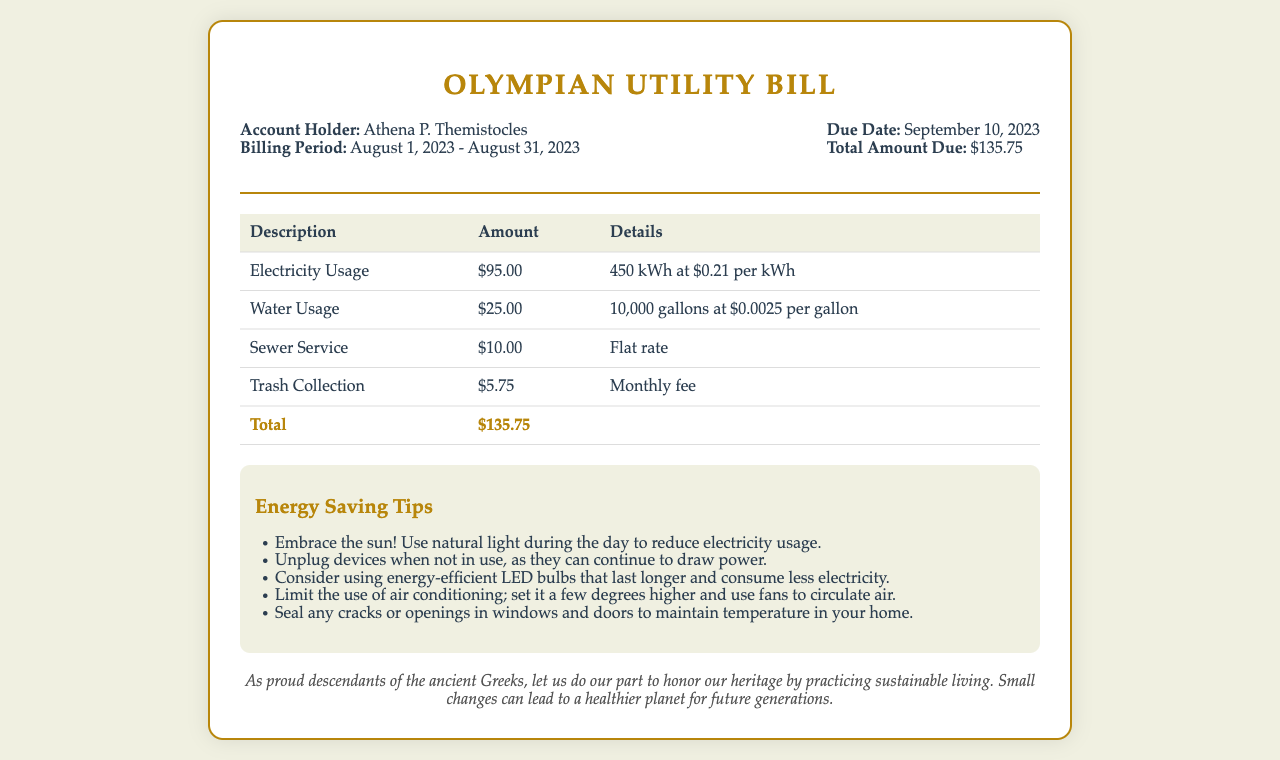What is the account holder's name? The account holder is identified in the document, which states "Account Holder: Athena P. Themistocles."
Answer: Athena P. Themistocles What is the billing period? The document specifies the duration of the billing period as "August 1, 2023 - August 31, 2023."
Answer: August 1, 2023 - August 31, 2023 What is the total amount due? The total amount due is presented clearly in the document as "Total Amount Due: $135.75."
Answer: $135.75 How much is charged for electricity usage? The breakdown indicates that electricity usage is charged as "Electricity Usage: $95.00."
Answer: $95.00 What was the water usage in gallons? The details for water usage are provided as "10,000 gallons at $0.0025 per gallon."
Answer: 10,000 gallons What are two energy-saving tips mentioned? The document provides various tips; selecting any two gives a clear response. For example, "Use natural light" and "Unplug devices."
Answer: Use natural light, Unplug devices How much was paid for trash collection? The fee for trash collection is specified as "Trash Collection: $5.75."
Answer: $5.75 What type of document is this? The title of the document indicates its purpose, stating "Olympian Utility Bill."
Answer: Utility Bill What is the due date? The due date is listed as "September 10, 2023."
Answer: September 10, 2023 How many kilowatt-hours were used? The document lists electricity usage as "450 kWh."
Answer: 450 kWh 